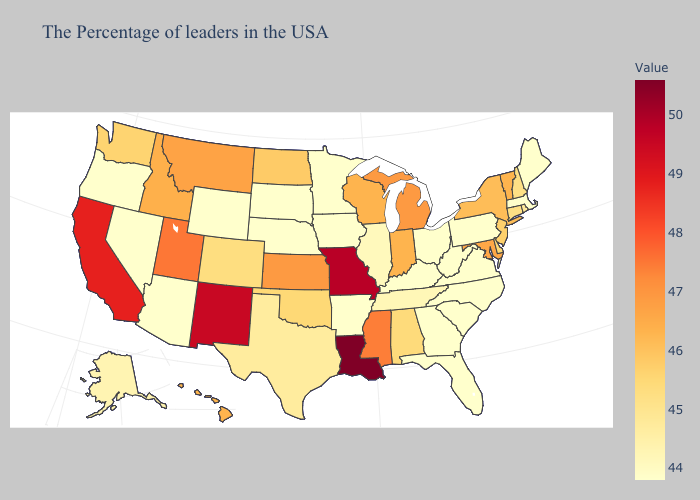Does the map have missing data?
Give a very brief answer. No. Does Vermont have the lowest value in the Northeast?
Short answer required. No. Does North Carolina have a lower value than Michigan?
Concise answer only. Yes. Does Louisiana have the highest value in the USA?
Be succinct. Yes. Does Mississippi have the highest value in the South?
Give a very brief answer. No. Among the states that border New Jersey , does New York have the highest value?
Quick response, please. Yes. Which states have the lowest value in the USA?
Answer briefly. Maine, Massachusetts, Pennsylvania, Virginia, North Carolina, South Carolina, West Virginia, Ohio, Florida, Georgia, Kentucky, Arkansas, Minnesota, Iowa, Nebraska, South Dakota, Wyoming, Arizona, Nevada, Oregon. Does Florida have the lowest value in the USA?
Write a very short answer. Yes. Which states have the lowest value in the Northeast?
Write a very short answer. Maine, Massachusetts, Pennsylvania. Does New Mexico have a lower value than South Dakota?
Answer briefly. No. Among the states that border North Carolina , which have the highest value?
Keep it brief. Tennessee. 